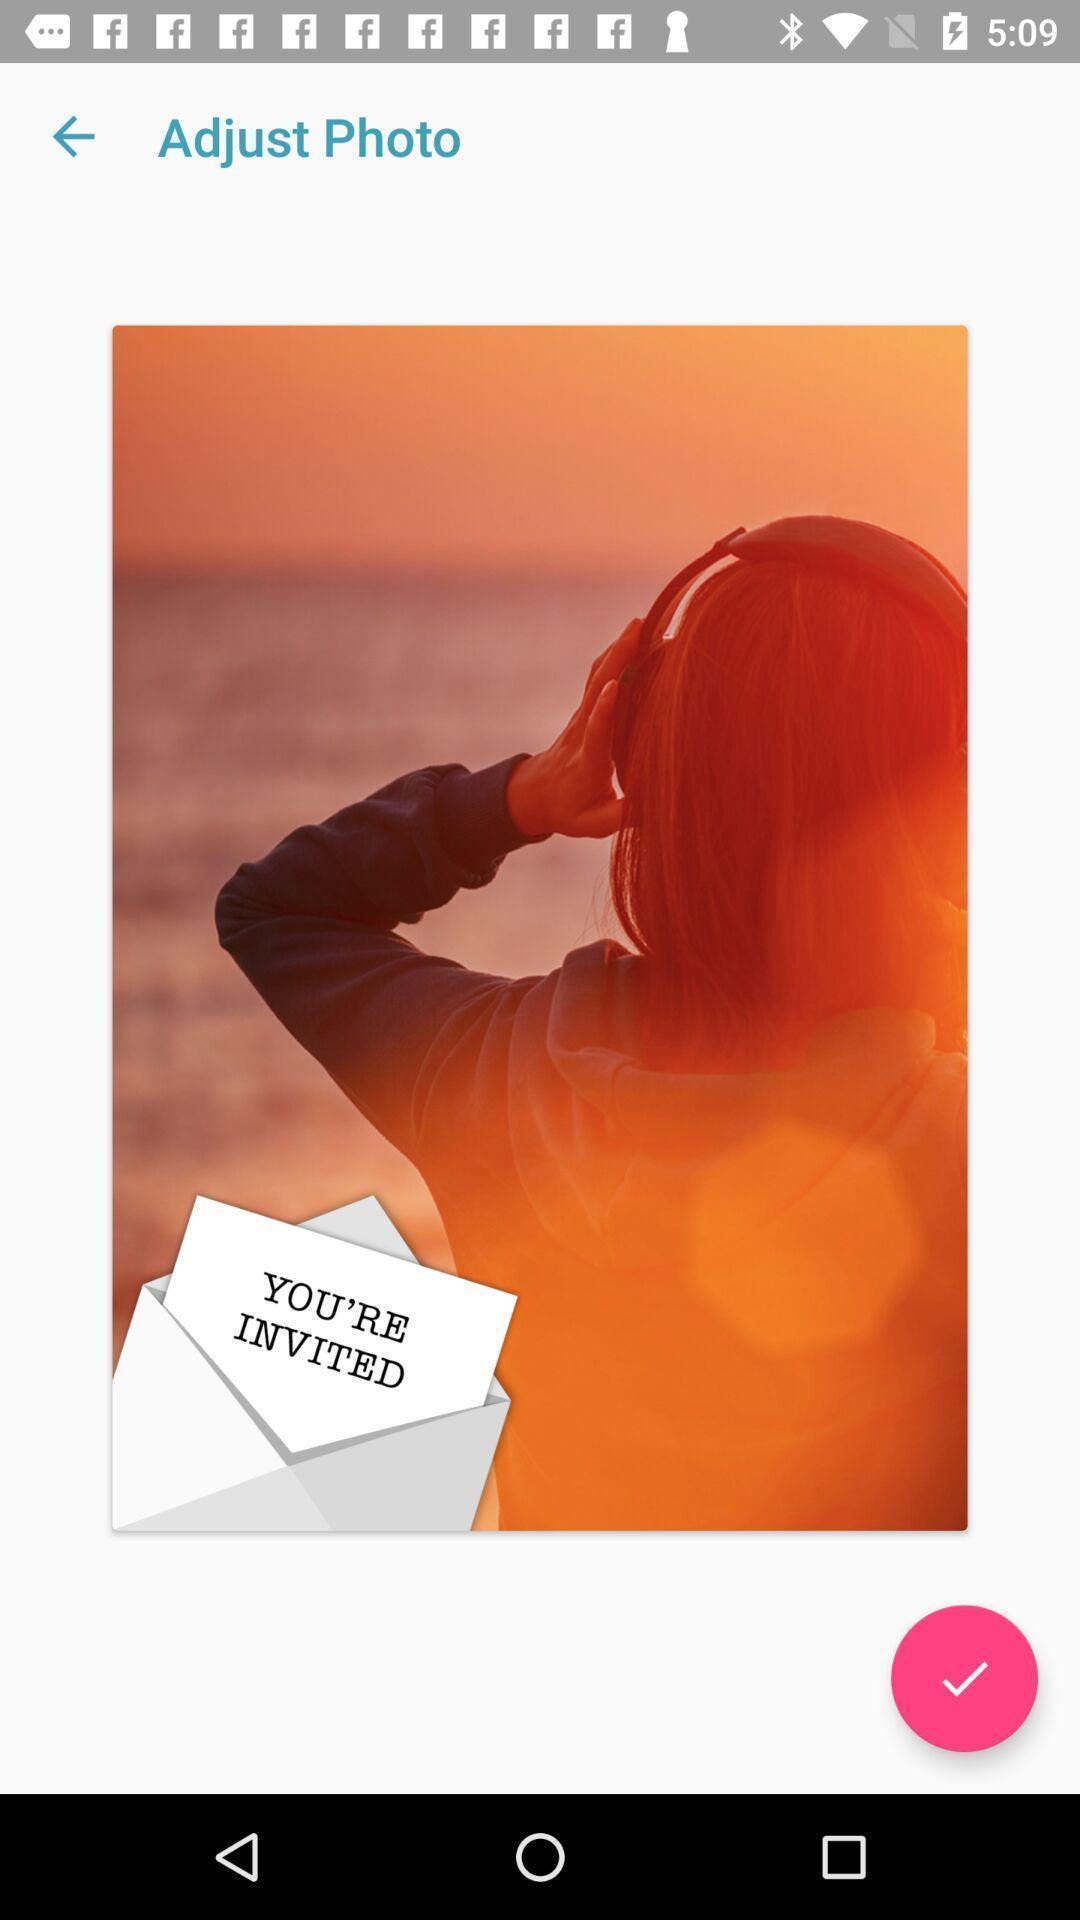What can you discern from this picture? Screen shows an image to edit. 